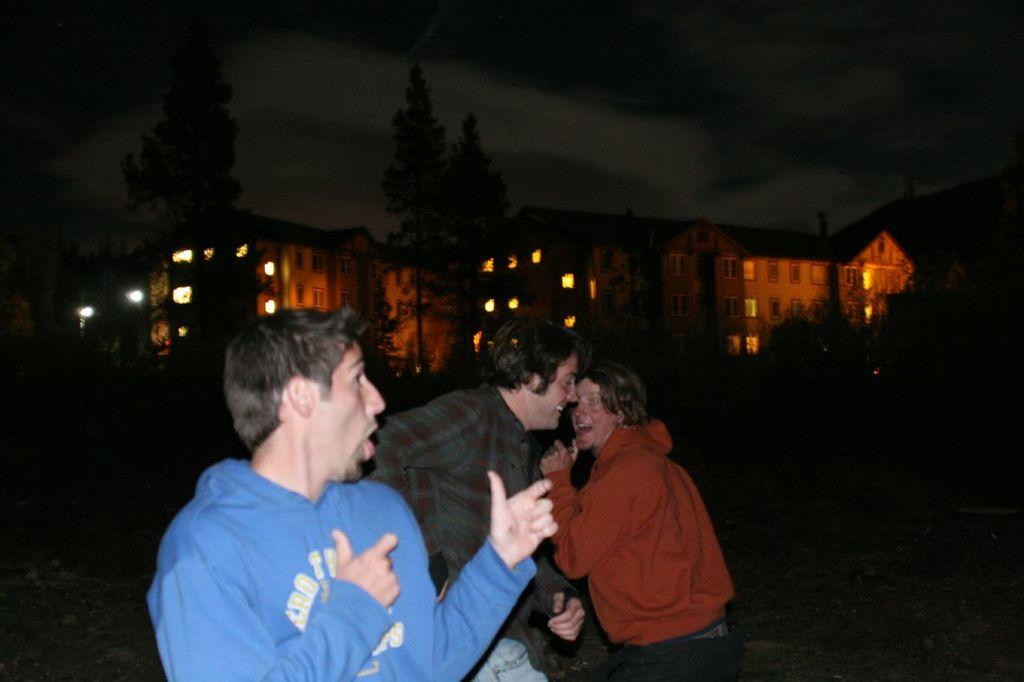How many people are in the image? There are three persons in the image. What can be seen behind the persons? There are trees and buildings behind the persons. Are there any lights visible in the buildings? Yes, lights are visible in the buildings. What type of disease is affecting the trees behind the persons in the image? There is no indication of any disease affecting the trees in the image; they appear to be healthy. 